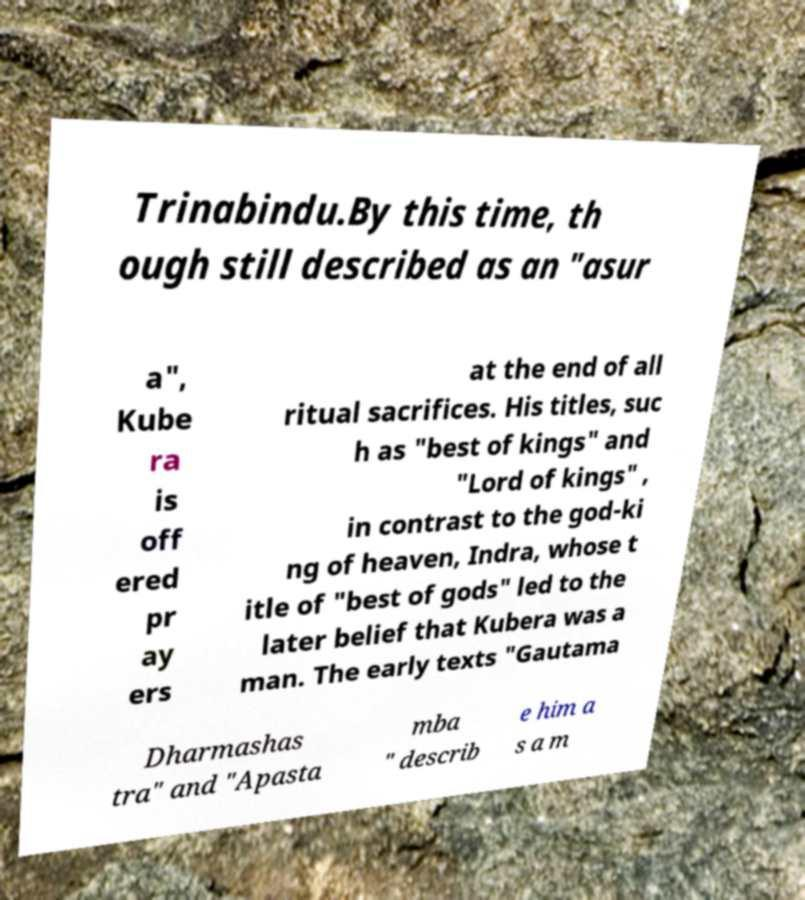Please read and relay the text visible in this image. What does it say? Trinabindu.By this time, th ough still described as an "asur a", Kube ra is off ered pr ay ers at the end of all ritual sacrifices. His titles, suc h as "best of kings" and "Lord of kings" , in contrast to the god-ki ng of heaven, Indra, whose t itle of "best of gods" led to the later belief that Kubera was a man. The early texts "Gautama Dharmashas tra" and "Apasta mba " describ e him a s a m 